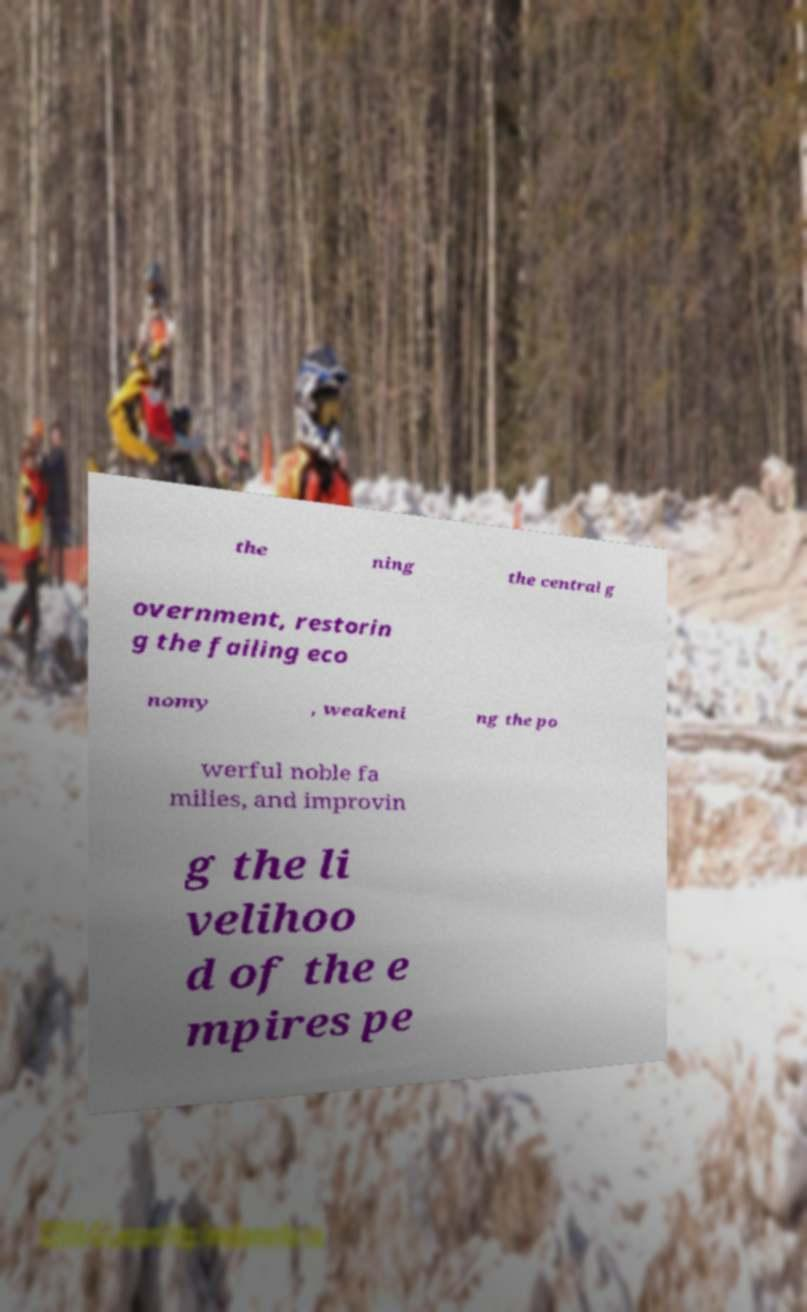Please identify and transcribe the text found in this image. the ning the central g overnment, restorin g the failing eco nomy , weakeni ng the po werful noble fa milies, and improvin g the li velihoo d of the e mpires pe 